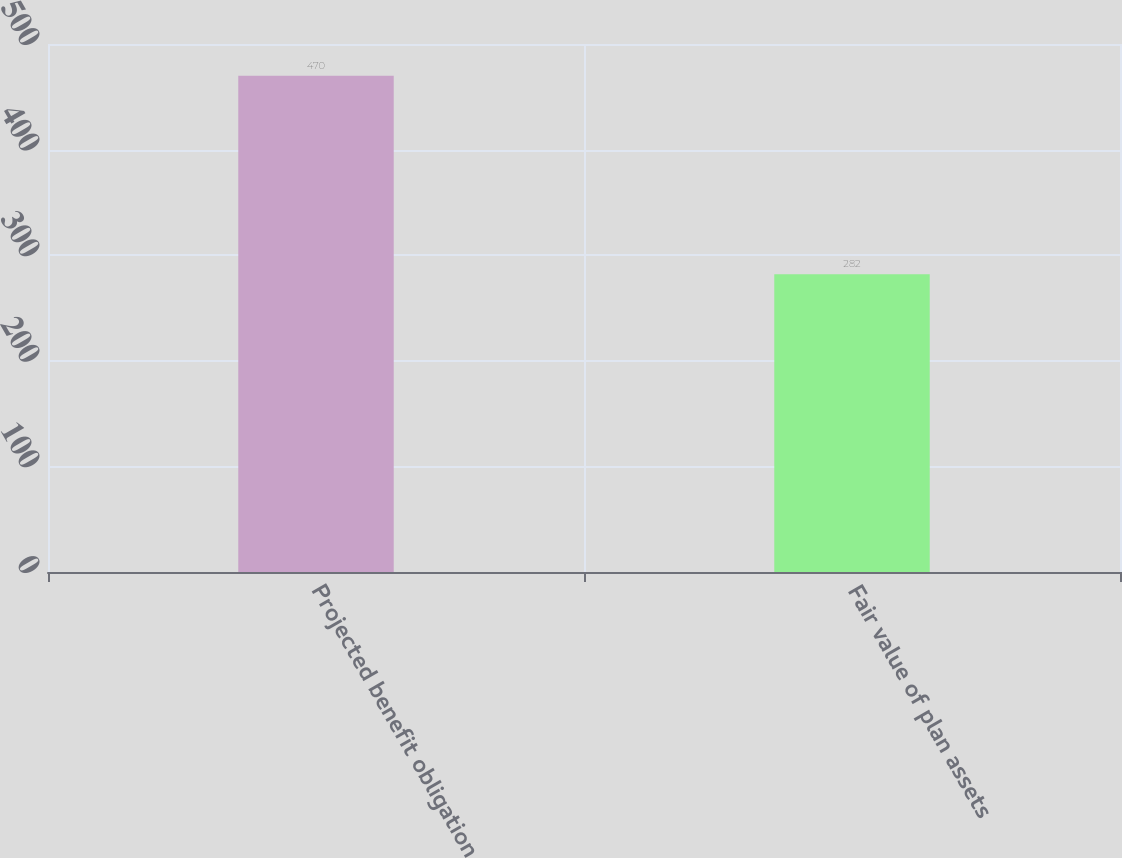<chart> <loc_0><loc_0><loc_500><loc_500><bar_chart><fcel>Projected benefit obligation<fcel>Fair value of plan assets<nl><fcel>470<fcel>282<nl></chart> 